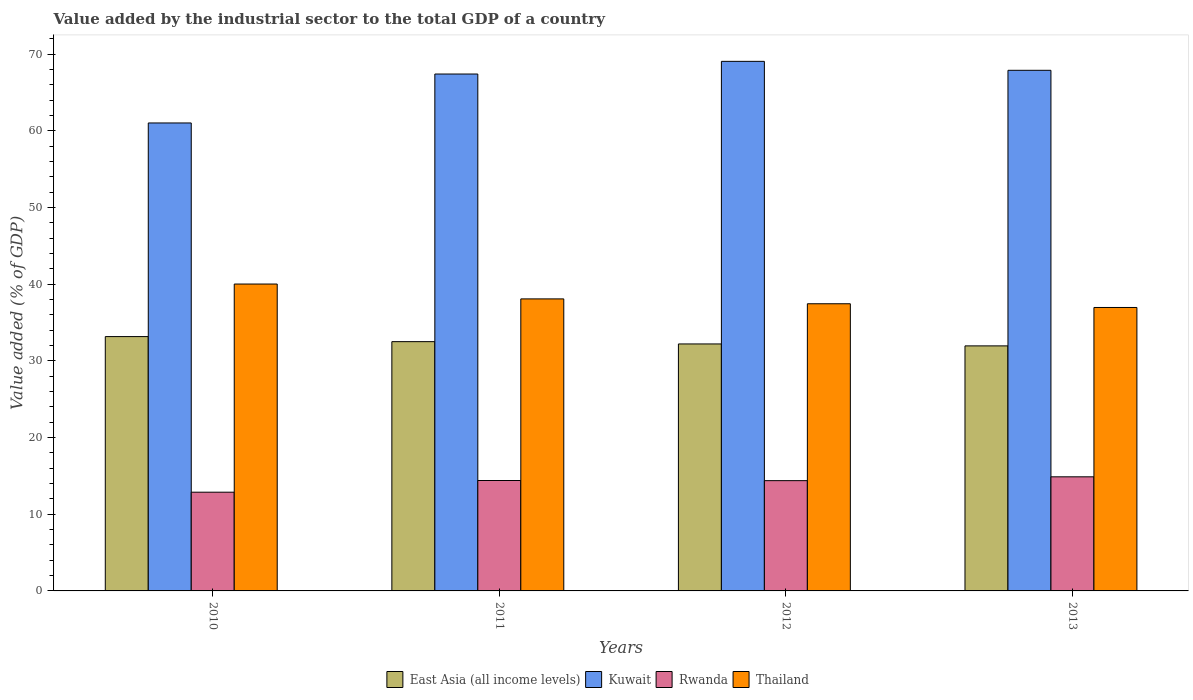How many different coloured bars are there?
Offer a terse response. 4. Are the number of bars per tick equal to the number of legend labels?
Offer a very short reply. Yes. Are the number of bars on each tick of the X-axis equal?
Your answer should be compact. Yes. How many bars are there on the 2nd tick from the right?
Your response must be concise. 4. What is the value added by the industrial sector to the total GDP in Thailand in 2010?
Offer a terse response. 40.03. Across all years, what is the maximum value added by the industrial sector to the total GDP in Rwanda?
Make the answer very short. 14.88. Across all years, what is the minimum value added by the industrial sector to the total GDP in Thailand?
Your answer should be very brief. 36.98. In which year was the value added by the industrial sector to the total GDP in Thailand maximum?
Give a very brief answer. 2010. In which year was the value added by the industrial sector to the total GDP in Rwanda minimum?
Keep it short and to the point. 2010. What is the total value added by the industrial sector to the total GDP in East Asia (all income levels) in the graph?
Your answer should be compact. 129.88. What is the difference between the value added by the industrial sector to the total GDP in East Asia (all income levels) in 2010 and that in 2013?
Your answer should be very brief. 1.21. What is the difference between the value added by the industrial sector to the total GDP in Thailand in 2011 and the value added by the industrial sector to the total GDP in Rwanda in 2010?
Make the answer very short. 25.21. What is the average value added by the industrial sector to the total GDP in East Asia (all income levels) per year?
Your response must be concise. 32.47. In the year 2013, what is the difference between the value added by the industrial sector to the total GDP in Rwanda and value added by the industrial sector to the total GDP in Kuwait?
Provide a succinct answer. -53.03. In how many years, is the value added by the industrial sector to the total GDP in East Asia (all income levels) greater than 44 %?
Offer a very short reply. 0. What is the ratio of the value added by the industrial sector to the total GDP in East Asia (all income levels) in 2010 to that in 2012?
Offer a very short reply. 1.03. Is the value added by the industrial sector to the total GDP in Thailand in 2011 less than that in 2013?
Ensure brevity in your answer.  No. Is the difference between the value added by the industrial sector to the total GDP in Rwanda in 2010 and 2011 greater than the difference between the value added by the industrial sector to the total GDP in Kuwait in 2010 and 2011?
Keep it short and to the point. Yes. What is the difference between the highest and the second highest value added by the industrial sector to the total GDP in East Asia (all income levels)?
Offer a terse response. 0.66. What is the difference between the highest and the lowest value added by the industrial sector to the total GDP in East Asia (all income levels)?
Give a very brief answer. 1.21. In how many years, is the value added by the industrial sector to the total GDP in East Asia (all income levels) greater than the average value added by the industrial sector to the total GDP in East Asia (all income levels) taken over all years?
Your response must be concise. 2. Is it the case that in every year, the sum of the value added by the industrial sector to the total GDP in Kuwait and value added by the industrial sector to the total GDP in East Asia (all income levels) is greater than the sum of value added by the industrial sector to the total GDP in Rwanda and value added by the industrial sector to the total GDP in Thailand?
Your answer should be very brief. No. What does the 1st bar from the left in 2013 represents?
Provide a succinct answer. East Asia (all income levels). What does the 4th bar from the right in 2011 represents?
Provide a short and direct response. East Asia (all income levels). Is it the case that in every year, the sum of the value added by the industrial sector to the total GDP in East Asia (all income levels) and value added by the industrial sector to the total GDP in Thailand is greater than the value added by the industrial sector to the total GDP in Kuwait?
Your answer should be compact. Yes. How many years are there in the graph?
Give a very brief answer. 4. What is the difference between two consecutive major ticks on the Y-axis?
Make the answer very short. 10. How many legend labels are there?
Your response must be concise. 4. How are the legend labels stacked?
Provide a succinct answer. Horizontal. What is the title of the graph?
Offer a very short reply. Value added by the industrial sector to the total GDP of a country. What is the label or title of the X-axis?
Keep it short and to the point. Years. What is the label or title of the Y-axis?
Ensure brevity in your answer.  Value added (% of GDP). What is the Value added (% of GDP) of East Asia (all income levels) in 2010?
Offer a terse response. 33.18. What is the Value added (% of GDP) in Kuwait in 2010?
Provide a succinct answer. 61.05. What is the Value added (% of GDP) of Rwanda in 2010?
Your answer should be very brief. 12.88. What is the Value added (% of GDP) of Thailand in 2010?
Your answer should be very brief. 40.03. What is the Value added (% of GDP) of East Asia (all income levels) in 2011?
Make the answer very short. 32.52. What is the Value added (% of GDP) of Kuwait in 2011?
Give a very brief answer. 67.43. What is the Value added (% of GDP) in Rwanda in 2011?
Provide a succinct answer. 14.4. What is the Value added (% of GDP) in Thailand in 2011?
Provide a short and direct response. 38.09. What is the Value added (% of GDP) in East Asia (all income levels) in 2012?
Your answer should be very brief. 32.22. What is the Value added (% of GDP) in Kuwait in 2012?
Provide a succinct answer. 69.08. What is the Value added (% of GDP) of Rwanda in 2012?
Your answer should be very brief. 14.39. What is the Value added (% of GDP) of Thailand in 2012?
Offer a terse response. 37.46. What is the Value added (% of GDP) in East Asia (all income levels) in 2013?
Your answer should be compact. 31.97. What is the Value added (% of GDP) in Kuwait in 2013?
Provide a succinct answer. 67.91. What is the Value added (% of GDP) of Rwanda in 2013?
Your response must be concise. 14.88. What is the Value added (% of GDP) in Thailand in 2013?
Offer a very short reply. 36.98. Across all years, what is the maximum Value added (% of GDP) in East Asia (all income levels)?
Your response must be concise. 33.18. Across all years, what is the maximum Value added (% of GDP) of Kuwait?
Your answer should be compact. 69.08. Across all years, what is the maximum Value added (% of GDP) in Rwanda?
Your response must be concise. 14.88. Across all years, what is the maximum Value added (% of GDP) in Thailand?
Offer a very short reply. 40.03. Across all years, what is the minimum Value added (% of GDP) of East Asia (all income levels)?
Make the answer very short. 31.97. Across all years, what is the minimum Value added (% of GDP) of Kuwait?
Keep it short and to the point. 61.05. Across all years, what is the minimum Value added (% of GDP) of Rwanda?
Your response must be concise. 12.88. Across all years, what is the minimum Value added (% of GDP) in Thailand?
Your answer should be compact. 36.98. What is the total Value added (% of GDP) of East Asia (all income levels) in the graph?
Give a very brief answer. 129.88. What is the total Value added (% of GDP) of Kuwait in the graph?
Ensure brevity in your answer.  265.47. What is the total Value added (% of GDP) of Rwanda in the graph?
Your answer should be compact. 56.55. What is the total Value added (% of GDP) in Thailand in the graph?
Your response must be concise. 152.56. What is the difference between the Value added (% of GDP) of East Asia (all income levels) in 2010 and that in 2011?
Your answer should be compact. 0.66. What is the difference between the Value added (% of GDP) of Kuwait in 2010 and that in 2011?
Make the answer very short. -6.38. What is the difference between the Value added (% of GDP) of Rwanda in 2010 and that in 2011?
Provide a succinct answer. -1.52. What is the difference between the Value added (% of GDP) in Thailand in 2010 and that in 2011?
Keep it short and to the point. 1.94. What is the difference between the Value added (% of GDP) of East Asia (all income levels) in 2010 and that in 2012?
Your response must be concise. 0.96. What is the difference between the Value added (% of GDP) in Kuwait in 2010 and that in 2012?
Give a very brief answer. -8.04. What is the difference between the Value added (% of GDP) in Rwanda in 2010 and that in 2012?
Your answer should be very brief. -1.51. What is the difference between the Value added (% of GDP) of Thailand in 2010 and that in 2012?
Make the answer very short. 2.57. What is the difference between the Value added (% of GDP) in East Asia (all income levels) in 2010 and that in 2013?
Make the answer very short. 1.21. What is the difference between the Value added (% of GDP) in Kuwait in 2010 and that in 2013?
Your answer should be very brief. -6.87. What is the difference between the Value added (% of GDP) in Rwanda in 2010 and that in 2013?
Ensure brevity in your answer.  -2. What is the difference between the Value added (% of GDP) of Thailand in 2010 and that in 2013?
Offer a terse response. 3.06. What is the difference between the Value added (% of GDP) of East Asia (all income levels) in 2011 and that in 2012?
Offer a terse response. 0.3. What is the difference between the Value added (% of GDP) in Kuwait in 2011 and that in 2012?
Offer a very short reply. -1.65. What is the difference between the Value added (% of GDP) in Rwanda in 2011 and that in 2012?
Your response must be concise. 0.02. What is the difference between the Value added (% of GDP) in Thailand in 2011 and that in 2012?
Keep it short and to the point. 0.63. What is the difference between the Value added (% of GDP) in East Asia (all income levels) in 2011 and that in 2013?
Give a very brief answer. 0.55. What is the difference between the Value added (% of GDP) of Kuwait in 2011 and that in 2013?
Your answer should be very brief. -0.48. What is the difference between the Value added (% of GDP) of Rwanda in 2011 and that in 2013?
Your response must be concise. -0.48. What is the difference between the Value added (% of GDP) in Thailand in 2011 and that in 2013?
Your response must be concise. 1.12. What is the difference between the Value added (% of GDP) of East Asia (all income levels) in 2012 and that in 2013?
Your response must be concise. 0.25. What is the difference between the Value added (% of GDP) of Kuwait in 2012 and that in 2013?
Ensure brevity in your answer.  1.17. What is the difference between the Value added (% of GDP) in Rwanda in 2012 and that in 2013?
Keep it short and to the point. -0.5. What is the difference between the Value added (% of GDP) in Thailand in 2012 and that in 2013?
Give a very brief answer. 0.49. What is the difference between the Value added (% of GDP) in East Asia (all income levels) in 2010 and the Value added (% of GDP) in Kuwait in 2011?
Ensure brevity in your answer.  -34.25. What is the difference between the Value added (% of GDP) in East Asia (all income levels) in 2010 and the Value added (% of GDP) in Rwanda in 2011?
Ensure brevity in your answer.  18.77. What is the difference between the Value added (% of GDP) of East Asia (all income levels) in 2010 and the Value added (% of GDP) of Thailand in 2011?
Provide a succinct answer. -4.92. What is the difference between the Value added (% of GDP) of Kuwait in 2010 and the Value added (% of GDP) of Rwanda in 2011?
Provide a short and direct response. 46.64. What is the difference between the Value added (% of GDP) in Kuwait in 2010 and the Value added (% of GDP) in Thailand in 2011?
Keep it short and to the point. 22.95. What is the difference between the Value added (% of GDP) in Rwanda in 2010 and the Value added (% of GDP) in Thailand in 2011?
Offer a terse response. -25.21. What is the difference between the Value added (% of GDP) in East Asia (all income levels) in 2010 and the Value added (% of GDP) in Kuwait in 2012?
Your answer should be compact. -35.9. What is the difference between the Value added (% of GDP) in East Asia (all income levels) in 2010 and the Value added (% of GDP) in Rwanda in 2012?
Your answer should be compact. 18.79. What is the difference between the Value added (% of GDP) in East Asia (all income levels) in 2010 and the Value added (% of GDP) in Thailand in 2012?
Make the answer very short. -4.28. What is the difference between the Value added (% of GDP) in Kuwait in 2010 and the Value added (% of GDP) in Rwanda in 2012?
Your answer should be very brief. 46.66. What is the difference between the Value added (% of GDP) in Kuwait in 2010 and the Value added (% of GDP) in Thailand in 2012?
Your answer should be very brief. 23.59. What is the difference between the Value added (% of GDP) of Rwanda in 2010 and the Value added (% of GDP) of Thailand in 2012?
Provide a short and direct response. -24.58. What is the difference between the Value added (% of GDP) of East Asia (all income levels) in 2010 and the Value added (% of GDP) of Kuwait in 2013?
Provide a succinct answer. -34.74. What is the difference between the Value added (% of GDP) in East Asia (all income levels) in 2010 and the Value added (% of GDP) in Rwanda in 2013?
Provide a short and direct response. 18.29. What is the difference between the Value added (% of GDP) of East Asia (all income levels) in 2010 and the Value added (% of GDP) of Thailand in 2013?
Make the answer very short. -3.8. What is the difference between the Value added (% of GDP) of Kuwait in 2010 and the Value added (% of GDP) of Rwanda in 2013?
Your answer should be very brief. 46.16. What is the difference between the Value added (% of GDP) in Kuwait in 2010 and the Value added (% of GDP) in Thailand in 2013?
Your answer should be very brief. 24.07. What is the difference between the Value added (% of GDP) of Rwanda in 2010 and the Value added (% of GDP) of Thailand in 2013?
Make the answer very short. -24.1. What is the difference between the Value added (% of GDP) in East Asia (all income levels) in 2011 and the Value added (% of GDP) in Kuwait in 2012?
Provide a short and direct response. -36.57. What is the difference between the Value added (% of GDP) of East Asia (all income levels) in 2011 and the Value added (% of GDP) of Rwanda in 2012?
Your answer should be compact. 18.13. What is the difference between the Value added (% of GDP) of East Asia (all income levels) in 2011 and the Value added (% of GDP) of Thailand in 2012?
Provide a short and direct response. -4.94. What is the difference between the Value added (% of GDP) of Kuwait in 2011 and the Value added (% of GDP) of Rwanda in 2012?
Your answer should be very brief. 53.04. What is the difference between the Value added (% of GDP) in Kuwait in 2011 and the Value added (% of GDP) in Thailand in 2012?
Offer a very short reply. 29.97. What is the difference between the Value added (% of GDP) of Rwanda in 2011 and the Value added (% of GDP) of Thailand in 2012?
Ensure brevity in your answer.  -23.06. What is the difference between the Value added (% of GDP) of East Asia (all income levels) in 2011 and the Value added (% of GDP) of Kuwait in 2013?
Your answer should be very brief. -35.4. What is the difference between the Value added (% of GDP) of East Asia (all income levels) in 2011 and the Value added (% of GDP) of Rwanda in 2013?
Provide a succinct answer. 17.63. What is the difference between the Value added (% of GDP) in East Asia (all income levels) in 2011 and the Value added (% of GDP) in Thailand in 2013?
Make the answer very short. -4.46. What is the difference between the Value added (% of GDP) of Kuwait in 2011 and the Value added (% of GDP) of Rwanda in 2013?
Your response must be concise. 52.54. What is the difference between the Value added (% of GDP) of Kuwait in 2011 and the Value added (% of GDP) of Thailand in 2013?
Keep it short and to the point. 30.45. What is the difference between the Value added (% of GDP) in Rwanda in 2011 and the Value added (% of GDP) in Thailand in 2013?
Offer a very short reply. -22.57. What is the difference between the Value added (% of GDP) in East Asia (all income levels) in 2012 and the Value added (% of GDP) in Kuwait in 2013?
Give a very brief answer. -35.7. What is the difference between the Value added (% of GDP) of East Asia (all income levels) in 2012 and the Value added (% of GDP) of Rwanda in 2013?
Provide a short and direct response. 17.33. What is the difference between the Value added (% of GDP) in East Asia (all income levels) in 2012 and the Value added (% of GDP) in Thailand in 2013?
Your answer should be very brief. -4.76. What is the difference between the Value added (% of GDP) of Kuwait in 2012 and the Value added (% of GDP) of Rwanda in 2013?
Offer a terse response. 54.2. What is the difference between the Value added (% of GDP) of Kuwait in 2012 and the Value added (% of GDP) of Thailand in 2013?
Make the answer very short. 32.11. What is the difference between the Value added (% of GDP) in Rwanda in 2012 and the Value added (% of GDP) in Thailand in 2013?
Your answer should be very brief. -22.59. What is the average Value added (% of GDP) of East Asia (all income levels) per year?
Your answer should be compact. 32.47. What is the average Value added (% of GDP) of Kuwait per year?
Offer a very short reply. 66.37. What is the average Value added (% of GDP) of Rwanda per year?
Make the answer very short. 14.14. What is the average Value added (% of GDP) in Thailand per year?
Your response must be concise. 38.14. In the year 2010, what is the difference between the Value added (% of GDP) of East Asia (all income levels) and Value added (% of GDP) of Kuwait?
Give a very brief answer. -27.87. In the year 2010, what is the difference between the Value added (% of GDP) of East Asia (all income levels) and Value added (% of GDP) of Rwanda?
Provide a succinct answer. 20.3. In the year 2010, what is the difference between the Value added (% of GDP) in East Asia (all income levels) and Value added (% of GDP) in Thailand?
Offer a very short reply. -6.85. In the year 2010, what is the difference between the Value added (% of GDP) in Kuwait and Value added (% of GDP) in Rwanda?
Make the answer very short. 48.17. In the year 2010, what is the difference between the Value added (% of GDP) of Kuwait and Value added (% of GDP) of Thailand?
Ensure brevity in your answer.  21.01. In the year 2010, what is the difference between the Value added (% of GDP) in Rwanda and Value added (% of GDP) in Thailand?
Provide a short and direct response. -27.15. In the year 2011, what is the difference between the Value added (% of GDP) in East Asia (all income levels) and Value added (% of GDP) in Kuwait?
Give a very brief answer. -34.91. In the year 2011, what is the difference between the Value added (% of GDP) in East Asia (all income levels) and Value added (% of GDP) in Rwanda?
Your response must be concise. 18.11. In the year 2011, what is the difference between the Value added (% of GDP) of East Asia (all income levels) and Value added (% of GDP) of Thailand?
Keep it short and to the point. -5.58. In the year 2011, what is the difference between the Value added (% of GDP) of Kuwait and Value added (% of GDP) of Rwanda?
Provide a short and direct response. 53.03. In the year 2011, what is the difference between the Value added (% of GDP) of Kuwait and Value added (% of GDP) of Thailand?
Provide a short and direct response. 29.34. In the year 2011, what is the difference between the Value added (% of GDP) in Rwanda and Value added (% of GDP) in Thailand?
Ensure brevity in your answer.  -23.69. In the year 2012, what is the difference between the Value added (% of GDP) of East Asia (all income levels) and Value added (% of GDP) of Kuwait?
Keep it short and to the point. -36.87. In the year 2012, what is the difference between the Value added (% of GDP) in East Asia (all income levels) and Value added (% of GDP) in Rwanda?
Make the answer very short. 17.83. In the year 2012, what is the difference between the Value added (% of GDP) in East Asia (all income levels) and Value added (% of GDP) in Thailand?
Your response must be concise. -5.24. In the year 2012, what is the difference between the Value added (% of GDP) of Kuwait and Value added (% of GDP) of Rwanda?
Ensure brevity in your answer.  54.7. In the year 2012, what is the difference between the Value added (% of GDP) in Kuwait and Value added (% of GDP) in Thailand?
Your answer should be compact. 31.62. In the year 2012, what is the difference between the Value added (% of GDP) of Rwanda and Value added (% of GDP) of Thailand?
Make the answer very short. -23.07. In the year 2013, what is the difference between the Value added (% of GDP) of East Asia (all income levels) and Value added (% of GDP) of Kuwait?
Give a very brief answer. -35.95. In the year 2013, what is the difference between the Value added (% of GDP) of East Asia (all income levels) and Value added (% of GDP) of Rwanda?
Make the answer very short. 17.08. In the year 2013, what is the difference between the Value added (% of GDP) of East Asia (all income levels) and Value added (% of GDP) of Thailand?
Your response must be concise. -5.01. In the year 2013, what is the difference between the Value added (% of GDP) of Kuwait and Value added (% of GDP) of Rwanda?
Your response must be concise. 53.03. In the year 2013, what is the difference between the Value added (% of GDP) of Kuwait and Value added (% of GDP) of Thailand?
Offer a terse response. 30.94. In the year 2013, what is the difference between the Value added (% of GDP) in Rwanda and Value added (% of GDP) in Thailand?
Ensure brevity in your answer.  -22.09. What is the ratio of the Value added (% of GDP) of East Asia (all income levels) in 2010 to that in 2011?
Offer a terse response. 1.02. What is the ratio of the Value added (% of GDP) in Kuwait in 2010 to that in 2011?
Your answer should be very brief. 0.91. What is the ratio of the Value added (% of GDP) of Rwanda in 2010 to that in 2011?
Keep it short and to the point. 0.89. What is the ratio of the Value added (% of GDP) in Thailand in 2010 to that in 2011?
Offer a very short reply. 1.05. What is the ratio of the Value added (% of GDP) of East Asia (all income levels) in 2010 to that in 2012?
Offer a very short reply. 1.03. What is the ratio of the Value added (% of GDP) of Kuwait in 2010 to that in 2012?
Provide a short and direct response. 0.88. What is the ratio of the Value added (% of GDP) of Rwanda in 2010 to that in 2012?
Ensure brevity in your answer.  0.9. What is the ratio of the Value added (% of GDP) of Thailand in 2010 to that in 2012?
Keep it short and to the point. 1.07. What is the ratio of the Value added (% of GDP) in East Asia (all income levels) in 2010 to that in 2013?
Ensure brevity in your answer.  1.04. What is the ratio of the Value added (% of GDP) in Kuwait in 2010 to that in 2013?
Your answer should be compact. 0.9. What is the ratio of the Value added (% of GDP) of Rwanda in 2010 to that in 2013?
Provide a short and direct response. 0.87. What is the ratio of the Value added (% of GDP) in Thailand in 2010 to that in 2013?
Make the answer very short. 1.08. What is the ratio of the Value added (% of GDP) in East Asia (all income levels) in 2011 to that in 2012?
Your answer should be compact. 1.01. What is the ratio of the Value added (% of GDP) of Kuwait in 2011 to that in 2012?
Ensure brevity in your answer.  0.98. What is the ratio of the Value added (% of GDP) in Rwanda in 2011 to that in 2012?
Make the answer very short. 1. What is the ratio of the Value added (% of GDP) of Thailand in 2011 to that in 2012?
Keep it short and to the point. 1.02. What is the ratio of the Value added (% of GDP) in East Asia (all income levels) in 2011 to that in 2013?
Provide a short and direct response. 1.02. What is the ratio of the Value added (% of GDP) of Kuwait in 2011 to that in 2013?
Your answer should be very brief. 0.99. What is the ratio of the Value added (% of GDP) of Rwanda in 2011 to that in 2013?
Offer a terse response. 0.97. What is the ratio of the Value added (% of GDP) in Thailand in 2011 to that in 2013?
Keep it short and to the point. 1.03. What is the ratio of the Value added (% of GDP) in East Asia (all income levels) in 2012 to that in 2013?
Your response must be concise. 1.01. What is the ratio of the Value added (% of GDP) in Kuwait in 2012 to that in 2013?
Ensure brevity in your answer.  1.02. What is the ratio of the Value added (% of GDP) in Rwanda in 2012 to that in 2013?
Offer a very short reply. 0.97. What is the ratio of the Value added (% of GDP) of Thailand in 2012 to that in 2013?
Provide a short and direct response. 1.01. What is the difference between the highest and the second highest Value added (% of GDP) of East Asia (all income levels)?
Keep it short and to the point. 0.66. What is the difference between the highest and the second highest Value added (% of GDP) in Kuwait?
Your answer should be compact. 1.17. What is the difference between the highest and the second highest Value added (% of GDP) of Rwanda?
Make the answer very short. 0.48. What is the difference between the highest and the second highest Value added (% of GDP) in Thailand?
Your answer should be compact. 1.94. What is the difference between the highest and the lowest Value added (% of GDP) of East Asia (all income levels)?
Offer a very short reply. 1.21. What is the difference between the highest and the lowest Value added (% of GDP) of Kuwait?
Offer a terse response. 8.04. What is the difference between the highest and the lowest Value added (% of GDP) in Rwanda?
Keep it short and to the point. 2. What is the difference between the highest and the lowest Value added (% of GDP) in Thailand?
Ensure brevity in your answer.  3.06. 